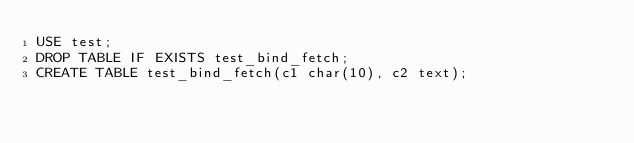<code> <loc_0><loc_0><loc_500><loc_500><_SQL_>USE test;
DROP TABLE IF EXISTS test_bind_fetch;
CREATE TABLE test_bind_fetch(c1 char(10), c2 text);
</code> 